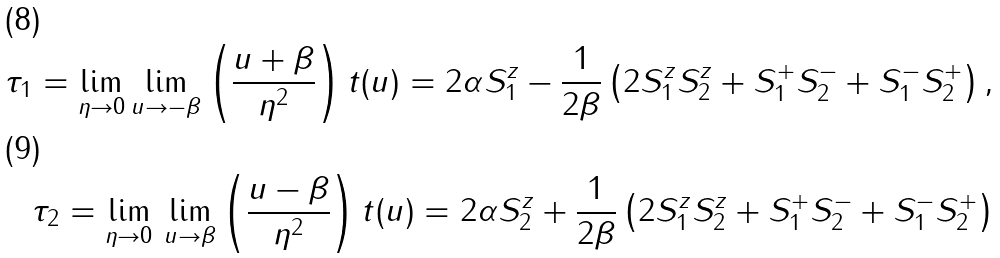<formula> <loc_0><loc_0><loc_500><loc_500>\tau _ { 1 } = \lim _ { \eta \rightarrow 0 } \lim _ { u \rightarrow - \beta } \left ( \frac { u + \beta } { \eta ^ { 2 } } \right ) t ( u ) = 2 \alpha S ^ { z } _ { 1 } - \frac { 1 } { 2 \beta } \left ( 2 S _ { 1 } ^ { z } S _ { 2 } ^ { z } + S ^ { + } _ { 1 } S ^ { - } _ { 2 } + S ^ { - } _ { 1 } S ^ { + } _ { 2 } \right ) , \\ \tau _ { 2 } = \lim _ { \eta \rightarrow 0 } \, \lim _ { u \rightarrow \beta } \left ( \frac { u - \beta } { \eta ^ { 2 } } \right ) t ( u ) = 2 \alpha S ^ { z } _ { 2 } + \frac { 1 } { 2 \beta } \left ( 2 S _ { 1 } ^ { z } S _ { 2 } ^ { z } + S ^ { + } _ { 1 } S ^ { - } _ { 2 } + S ^ { - } _ { 1 } S ^ { + } _ { 2 } \right )</formula> 